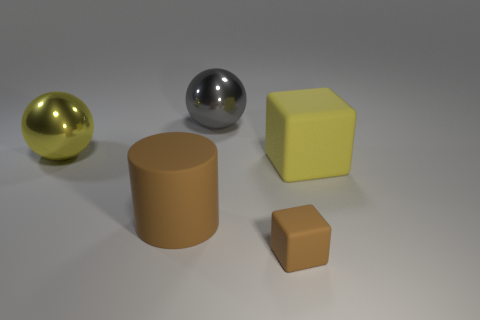Subtract 1 cubes. How many cubes are left? 1 Subtract all cylinders. How many objects are left? 4 Add 2 small blue shiny blocks. How many objects exist? 7 Add 5 big cylinders. How many big cylinders exist? 6 Subtract 0 red balls. How many objects are left? 5 Subtract all yellow cylinders. Subtract all cyan blocks. How many cylinders are left? 1 Subtract all green balls. How many blue cubes are left? 0 Subtract all gray shiny things. Subtract all gray objects. How many objects are left? 3 Add 4 large gray balls. How many large gray balls are left? 5 